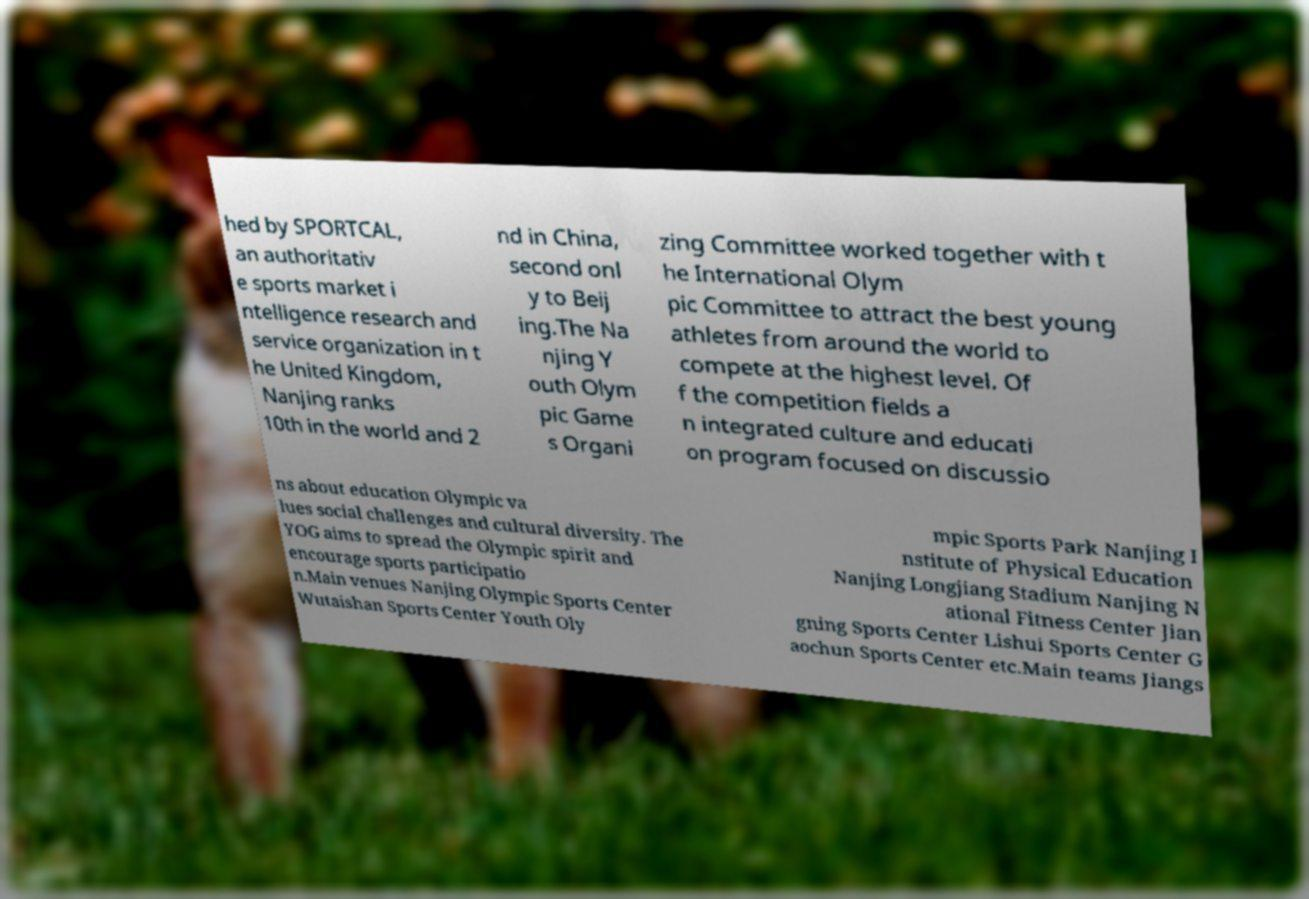Please read and relay the text visible in this image. What does it say? hed by SPORTCAL, an authoritativ e sports market i ntelligence research and service organization in t he United Kingdom, Nanjing ranks 10th in the world and 2 nd in China, second onl y to Beij ing.The Na njing Y outh Olym pic Game s Organi zing Committee worked together with t he International Olym pic Committee to attract the best young athletes from around the world to compete at the highest level. Of f the competition fields a n integrated culture and educati on program focused on discussio ns about education Olympic va lues social challenges and cultural diversity. The YOG aims to spread the Olympic spirit and encourage sports participatio n.Main venues Nanjing Olympic Sports Center Wutaishan Sports Center Youth Oly mpic Sports Park Nanjing I nstitute of Physical Education Nanjing Longjiang Stadium Nanjing N ational Fitness Center Jian gning Sports Center Lishui Sports Center G aochun Sports Center etc.Main teams Jiangs 